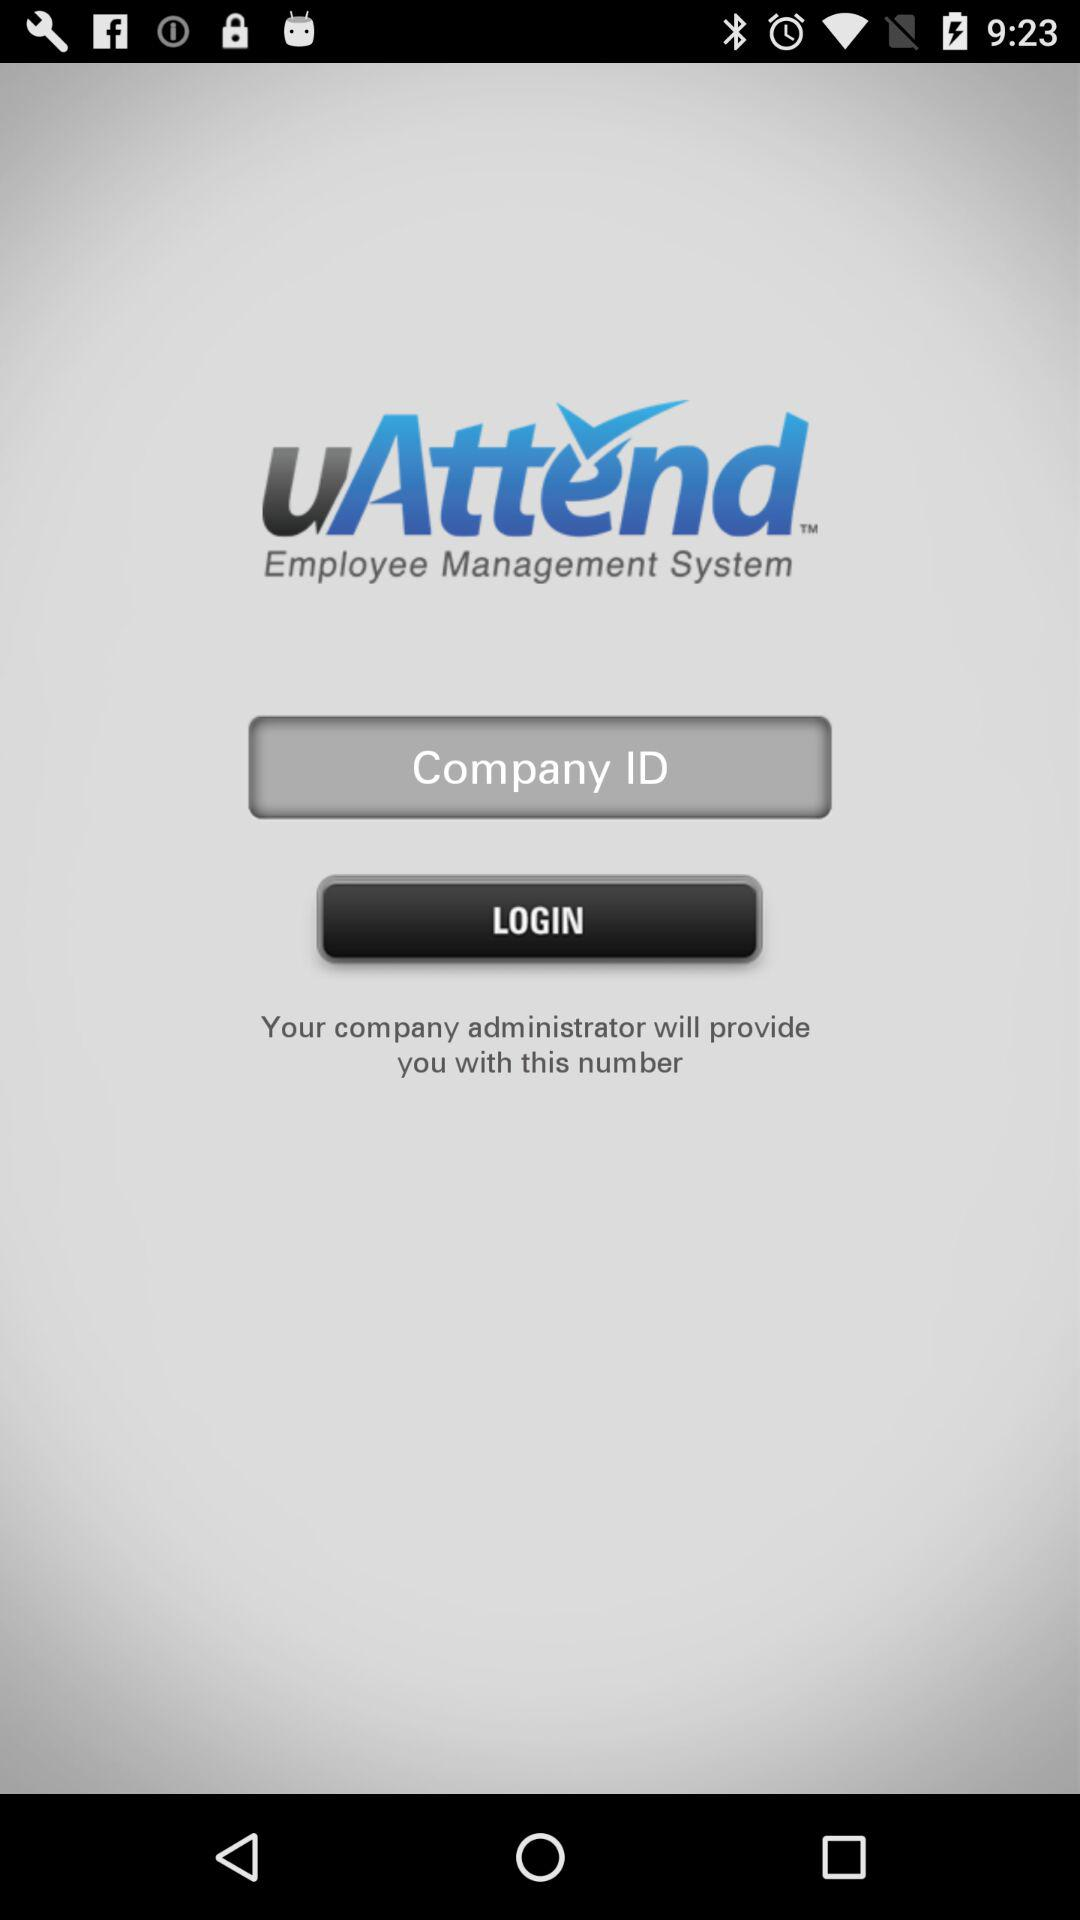What is the application name? The application name is "uAttend". 